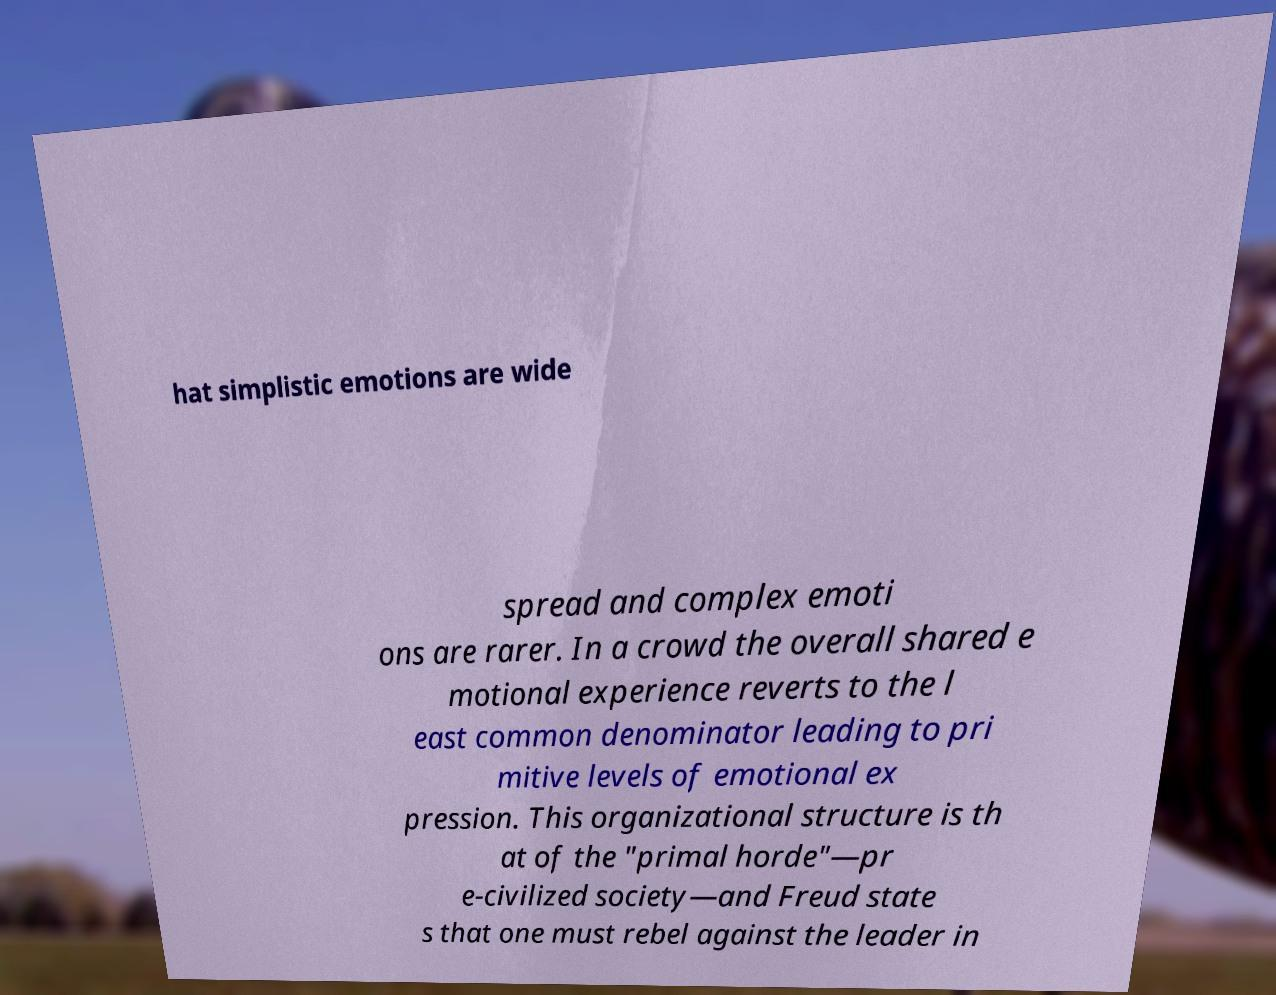Please read and relay the text visible in this image. What does it say? hat simplistic emotions are wide spread and complex emoti ons are rarer. In a crowd the overall shared e motional experience reverts to the l east common denominator leading to pri mitive levels of emotional ex pression. This organizational structure is th at of the "primal horde"—pr e-civilized society—and Freud state s that one must rebel against the leader in 